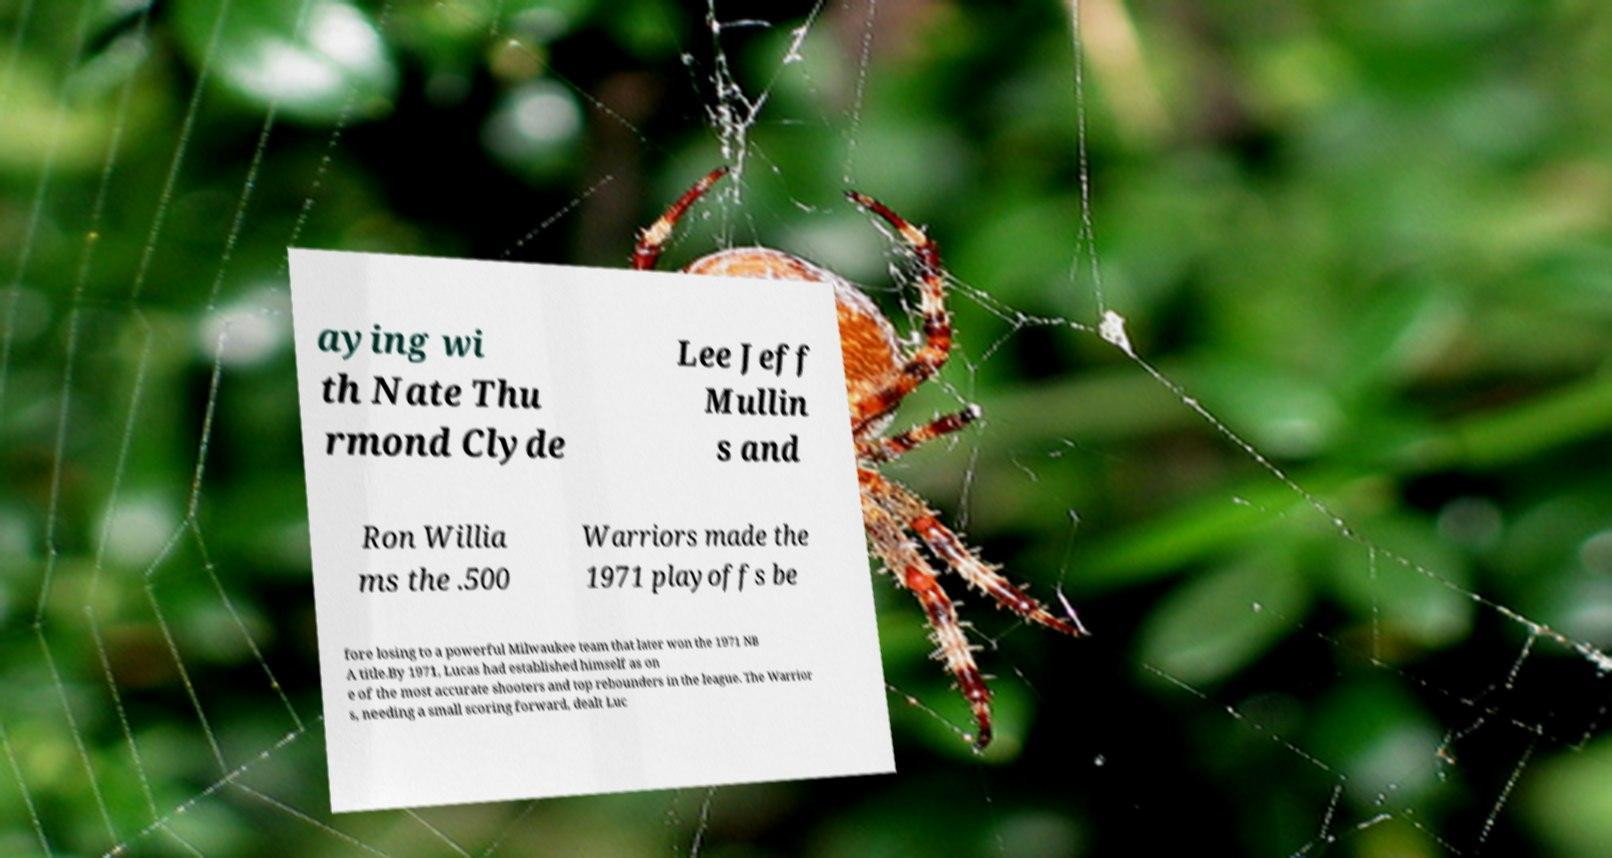Please read and relay the text visible in this image. What does it say? aying wi th Nate Thu rmond Clyde Lee Jeff Mullin s and Ron Willia ms the .500 Warriors made the 1971 playoffs be fore losing to a powerful Milwaukee team that later won the 1971 NB A title.By 1971, Lucas had established himself as on e of the most accurate shooters and top rebounders in the league. The Warrior s, needing a small scoring forward, dealt Luc 